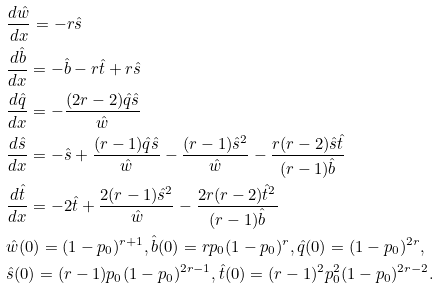<formula> <loc_0><loc_0><loc_500><loc_500>& \frac { d \hat { w } } { d x } = - r \hat { s } \\ & \frac { d \hat { b } } { d x } = - \hat { b } - r \hat { t } + r \hat { s } \\ & \frac { d \hat { q } } { d x } = - \frac { ( 2 r - 2 ) \hat { q } \hat { s } } { \hat { w } } \\ & \frac { d \hat { s } } { d x } = - \hat { s } + \frac { ( r - 1 ) \hat { q } \hat { s } } { \hat { w } } - \frac { ( r - 1 ) \hat { s } ^ { 2 } } { \hat { w } } - \frac { r ( r - 2 ) \hat { s } \hat { t } } { ( r - 1 ) \hat { b } } \\ & \frac { d \hat { t } } { d x } = - 2 \hat { t } + \frac { 2 ( r - 1 ) \hat { s } ^ { 2 } } { \hat { w } } - \frac { 2 r ( r - 2 ) \hat { t } ^ { 2 } } { ( r - 1 ) \hat { b } } \\ & \hat { w } ( 0 ) = ( 1 - p _ { 0 } ) ^ { r + 1 } , \hat { b } ( 0 ) = r p _ { 0 } ( 1 - p _ { 0 } ) ^ { r } , \hat { q } ( 0 ) = ( 1 - p _ { 0 } ) ^ { 2 r } , \\ & \hat { s } ( 0 ) = ( r - 1 ) p _ { 0 } ( 1 - p _ { 0 } ) ^ { 2 r - 1 } , \hat { t } ( 0 ) = ( r - 1 ) ^ { 2 } p _ { 0 } ^ { 2 } ( 1 - p _ { 0 } ) ^ { 2 r - 2 } .</formula> 